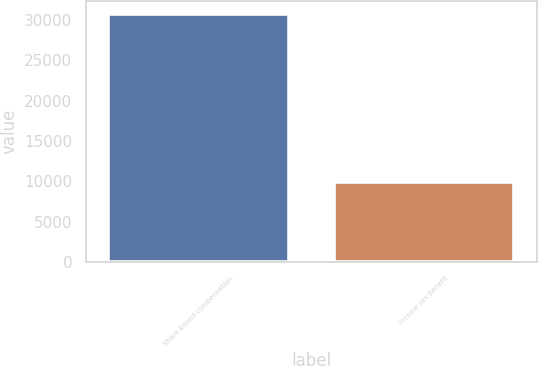<chart> <loc_0><loc_0><loc_500><loc_500><bar_chart><fcel>Share-based compensation<fcel>Income tax benefit<nl><fcel>30809<fcel>9879<nl></chart> 